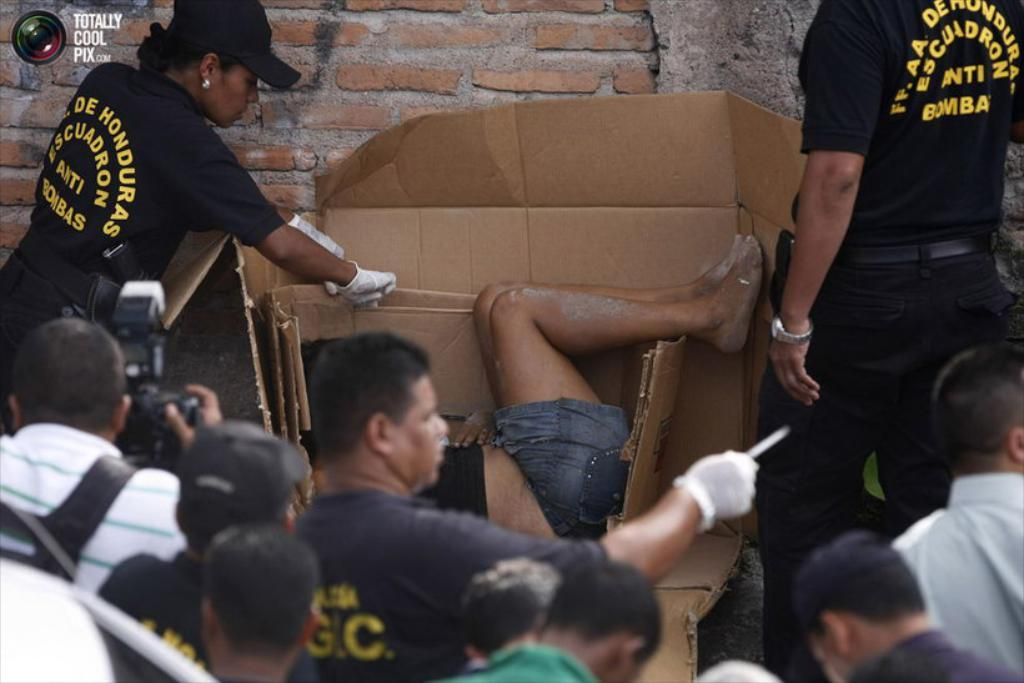How many people are in the image? There are a few people in the image. What is located behind the people in the image? There is a wall in the image. What objects can be seen near the people in the image? There are cardboard boxes in the image. Is there any text or logo visible in the image? Yes, there is a watermark in the top left corner of the image. What type of breakfast is being served in the image? There is no breakfast visible in the image. Can you tell me the title of the image? The image does not have a title, as it is a photograph or illustration and not a piece of text. 